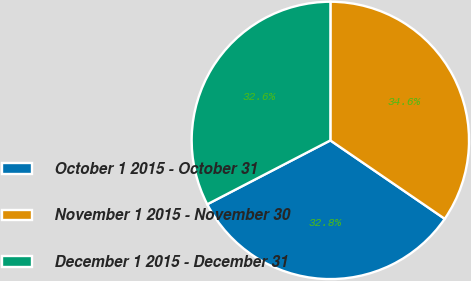Convert chart. <chart><loc_0><loc_0><loc_500><loc_500><pie_chart><fcel>October 1 2015 - October 31<fcel>November 1 2015 - November 30<fcel>December 1 2015 - December 31<nl><fcel>32.82%<fcel>34.56%<fcel>32.63%<nl></chart> 